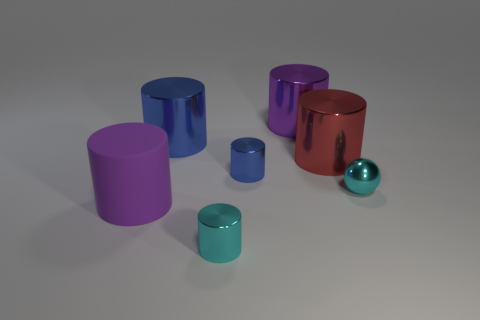Subtract all big blue cylinders. How many cylinders are left? 5 Add 2 red cylinders. How many objects exist? 9 Subtract all blue cylinders. How many cylinders are left? 4 Subtract 6 cylinders. How many cylinders are left? 0 Subtract all gray cubes. How many purple cylinders are left? 2 Subtract 0 yellow balls. How many objects are left? 7 Subtract all cylinders. How many objects are left? 1 Subtract all green spheres. Subtract all yellow cylinders. How many spheres are left? 1 Subtract all brown matte balls. Subtract all big purple matte cylinders. How many objects are left? 6 Add 6 purple metal objects. How many purple metal objects are left? 7 